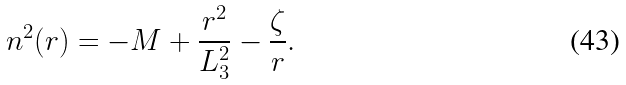<formula> <loc_0><loc_0><loc_500><loc_500>n ^ { 2 } ( r ) = - M + \frac { r ^ { 2 } } { L _ { 3 } ^ { 2 } } - \frac { \zeta } { r } .</formula> 